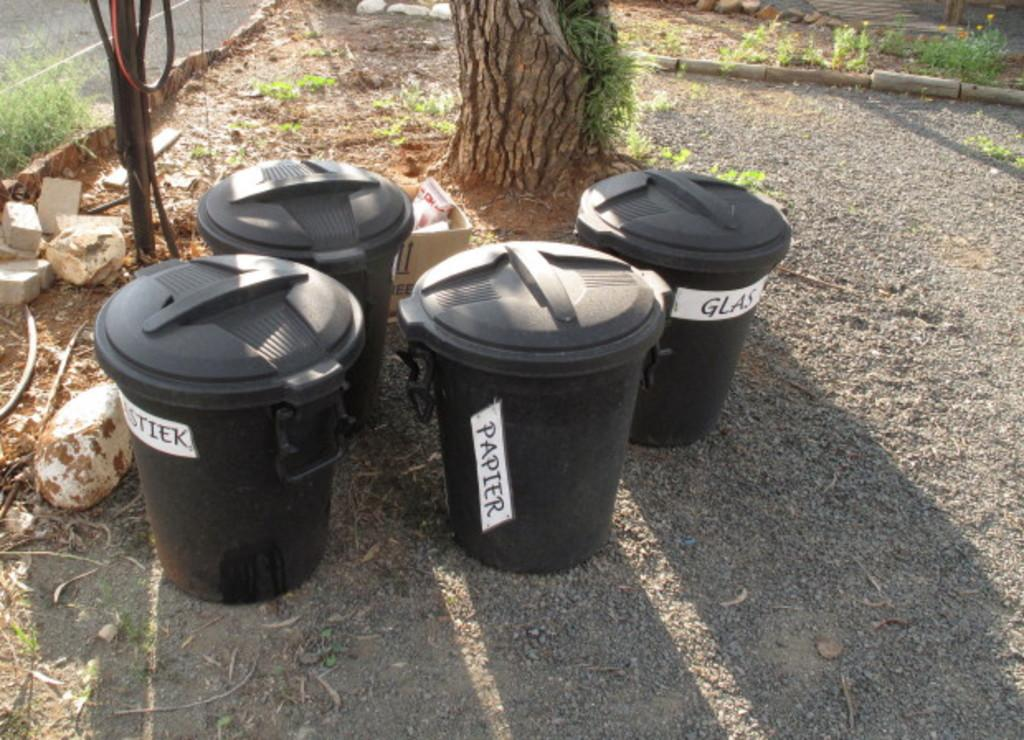<image>
Present a compact description of the photo's key features. Four black garbage pails are labeled for paper and glass. 